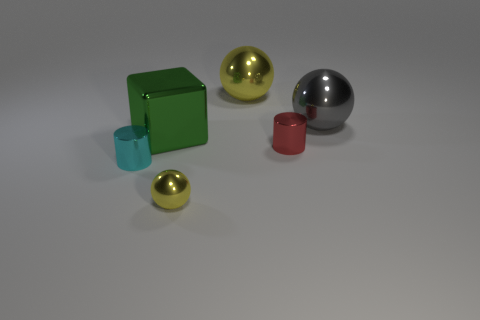What color is the cylinder left of the yellow metal ball that is in front of the small shiny cylinder right of the big metallic cube?
Your response must be concise. Cyan. Is there a small purple shiny thing of the same shape as the red thing?
Your answer should be compact. No. Are there more large balls that are to the left of the tiny yellow ball than tiny cyan things?
Offer a terse response. No. How many metallic things are gray cubes or large yellow spheres?
Make the answer very short. 1. There is a thing that is in front of the red cylinder and on the right side of the shiny cube; what is its size?
Keep it short and to the point. Small. Are there any large objects to the right of the large gray ball that is to the right of the large green shiny block?
Your answer should be compact. No. What number of gray balls are to the right of the tiny yellow ball?
Your response must be concise. 1. What is the color of the other small thing that is the same shape as the tiny red object?
Provide a short and direct response. Cyan. Is the yellow thing that is behind the small cyan metal cylinder made of the same material as the large object that is in front of the gray metallic sphere?
Your response must be concise. Yes. Do the big shiny cube and the tiny metal cylinder that is right of the big green metal thing have the same color?
Make the answer very short. No. 